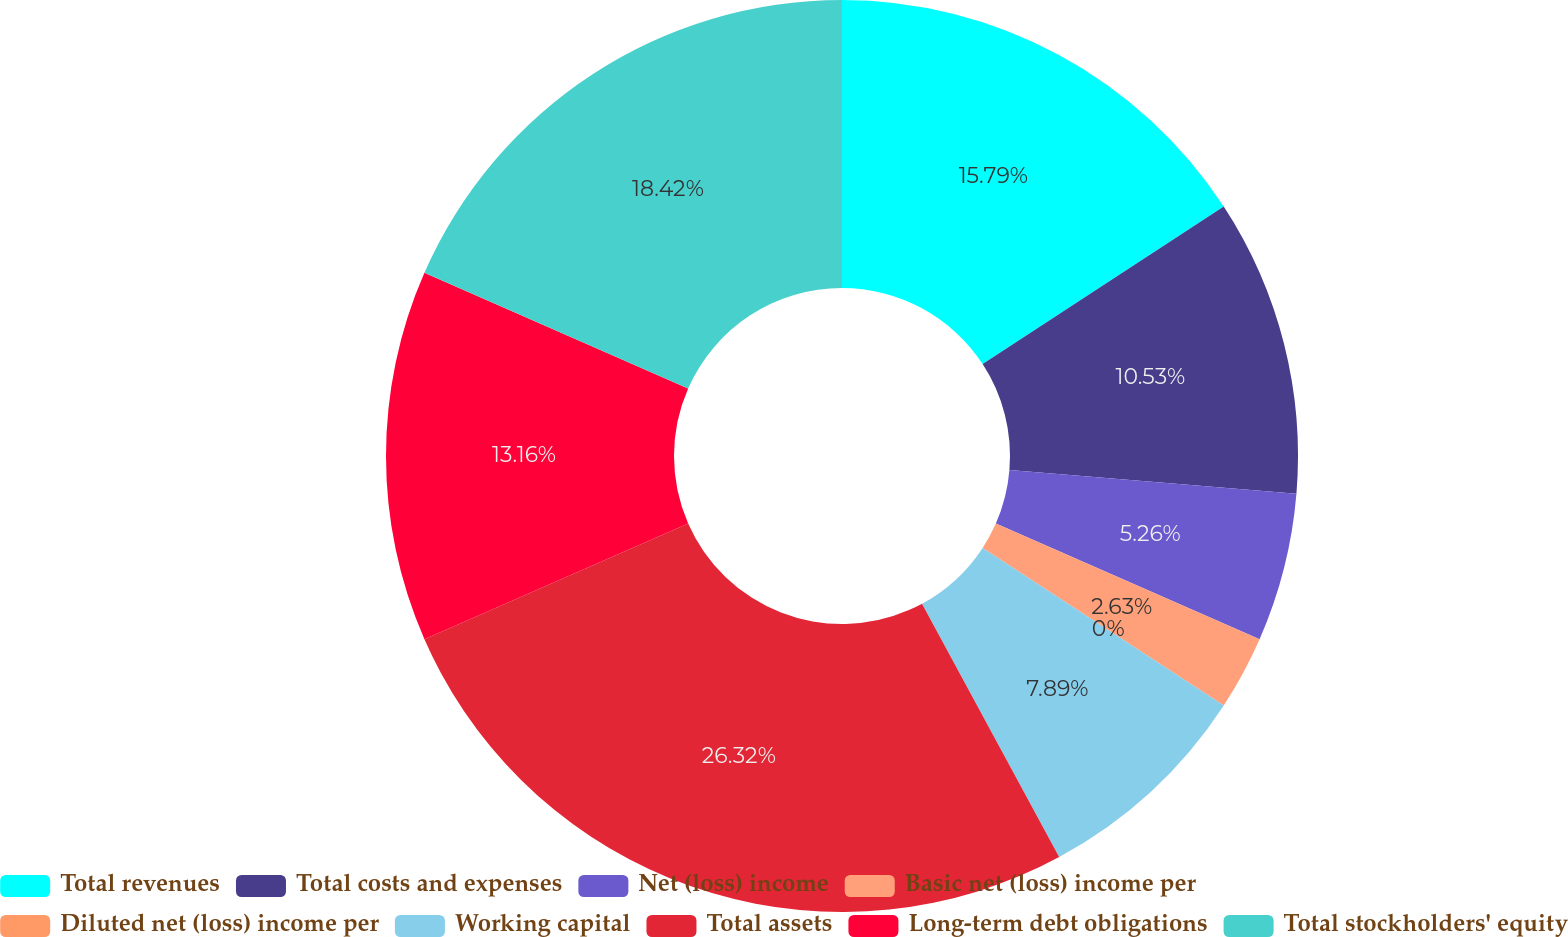Convert chart to OTSL. <chart><loc_0><loc_0><loc_500><loc_500><pie_chart><fcel>Total revenues<fcel>Total costs and expenses<fcel>Net (loss) income<fcel>Basic net (loss) income per<fcel>Diluted net (loss) income per<fcel>Working capital<fcel>Total assets<fcel>Long-term debt obligations<fcel>Total stockholders' equity<nl><fcel>15.79%<fcel>10.53%<fcel>5.26%<fcel>2.63%<fcel>0.0%<fcel>7.89%<fcel>26.32%<fcel>13.16%<fcel>18.42%<nl></chart> 